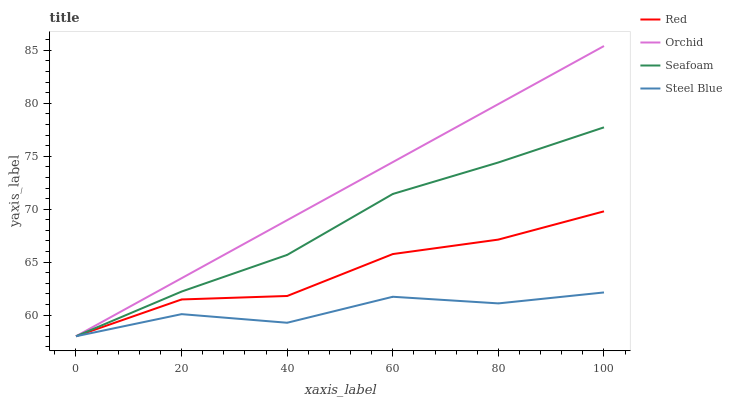Does Steel Blue have the minimum area under the curve?
Answer yes or no. Yes. Does Orchid have the maximum area under the curve?
Answer yes or no. Yes. Does Seafoam have the minimum area under the curve?
Answer yes or no. No. Does Seafoam have the maximum area under the curve?
Answer yes or no. No. Is Orchid the smoothest?
Answer yes or no. Yes. Is Steel Blue the roughest?
Answer yes or no. Yes. Is Seafoam the smoothest?
Answer yes or no. No. Is Seafoam the roughest?
Answer yes or no. No. Does Steel Blue have the lowest value?
Answer yes or no. Yes. Does Orchid have the highest value?
Answer yes or no. Yes. Does Seafoam have the highest value?
Answer yes or no. No. Does Seafoam intersect Steel Blue?
Answer yes or no. Yes. Is Seafoam less than Steel Blue?
Answer yes or no. No. Is Seafoam greater than Steel Blue?
Answer yes or no. No. 